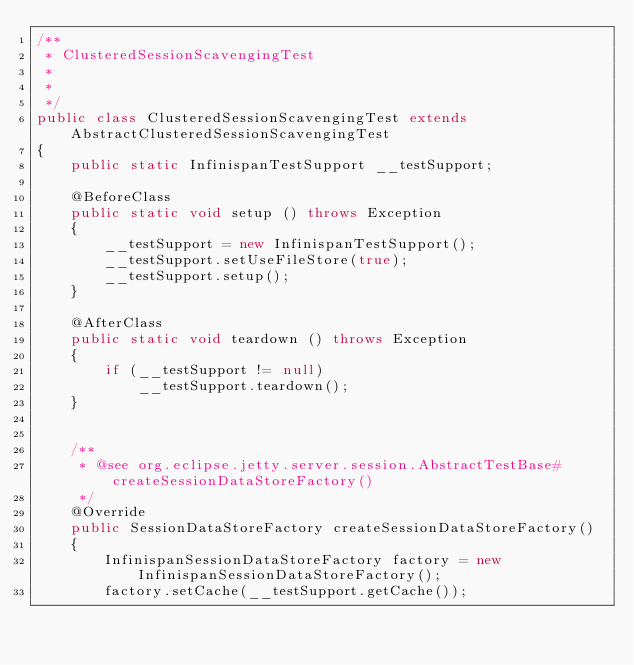Convert code to text. <code><loc_0><loc_0><loc_500><loc_500><_Java_>/**
 * ClusteredSessionScavengingTest
 *
 *
 */
public class ClusteredSessionScavengingTest extends AbstractClusteredSessionScavengingTest
{
    public static InfinispanTestSupport __testSupport;
    
    @BeforeClass
    public static void setup () throws Exception
    {
        __testSupport = new InfinispanTestSupport();
        __testSupport.setUseFileStore(true);
        __testSupport.setup();
    }
    
    @AfterClass
    public static void teardown () throws Exception
    {
        if (__testSupport != null)
            __testSupport.teardown();
    }


    /** 
     * @see org.eclipse.jetty.server.session.AbstractTestBase#createSessionDataStoreFactory()
     */
    @Override
    public SessionDataStoreFactory createSessionDataStoreFactory()
    {
        InfinispanSessionDataStoreFactory factory = new InfinispanSessionDataStoreFactory();
        factory.setCache(__testSupport.getCache());</code> 